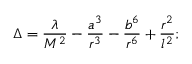Convert formula to latex. <formula><loc_0><loc_0><loc_500><loc_500>\Delta = \frac { \lambda } { M ^ { 2 } } - \frac { a ^ { 3 } } { r ^ { 3 } } - \frac { b ^ { 6 } } { r ^ { 6 } } + \frac { r ^ { 2 } } { l ^ { 2 } } ;</formula> 